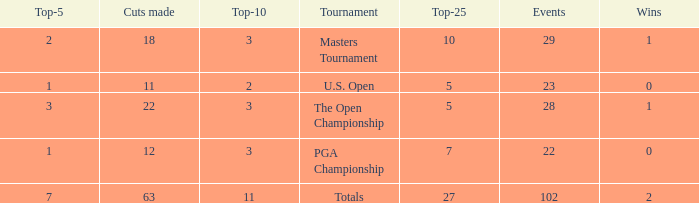I'm looking to parse the entire table for insights. Could you assist me with that? {'header': ['Top-5', 'Cuts made', 'Top-10', 'Tournament', 'Top-25', 'Events', 'Wins'], 'rows': [['2', '18', '3', 'Masters Tournament', '10', '29', '1'], ['1', '11', '2', 'U.S. Open', '5', '23', '0'], ['3', '22', '3', 'The Open Championship', '5', '28', '1'], ['1', '12', '3', 'PGA Championship', '7', '22', '0'], ['7', '63', '11', 'Totals', '27', '102', '2']]} How many top 10s did he have when he had fewer than 1 top 5? None. 